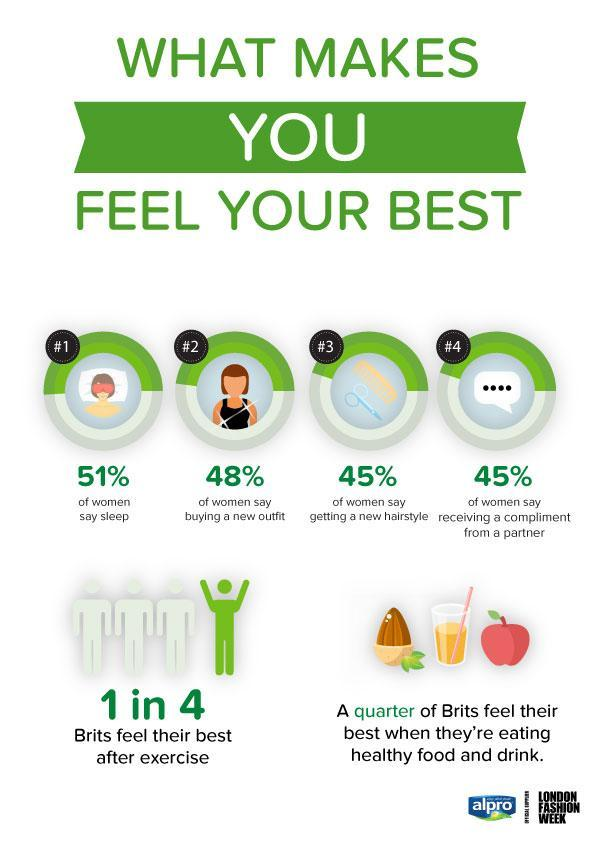WHat % of women feel that sleep makes them feel their best
Answer the question with a short phrase. 51% What are the 3rd and 4th factor that make women feel their best getting a new hairstyle, receiving a compliment from a partner What are people from Britain called Brits What % of Brits feel their best after excercise 25 How many feel their best when they're eating healthy food and drink A quarter of Brits 